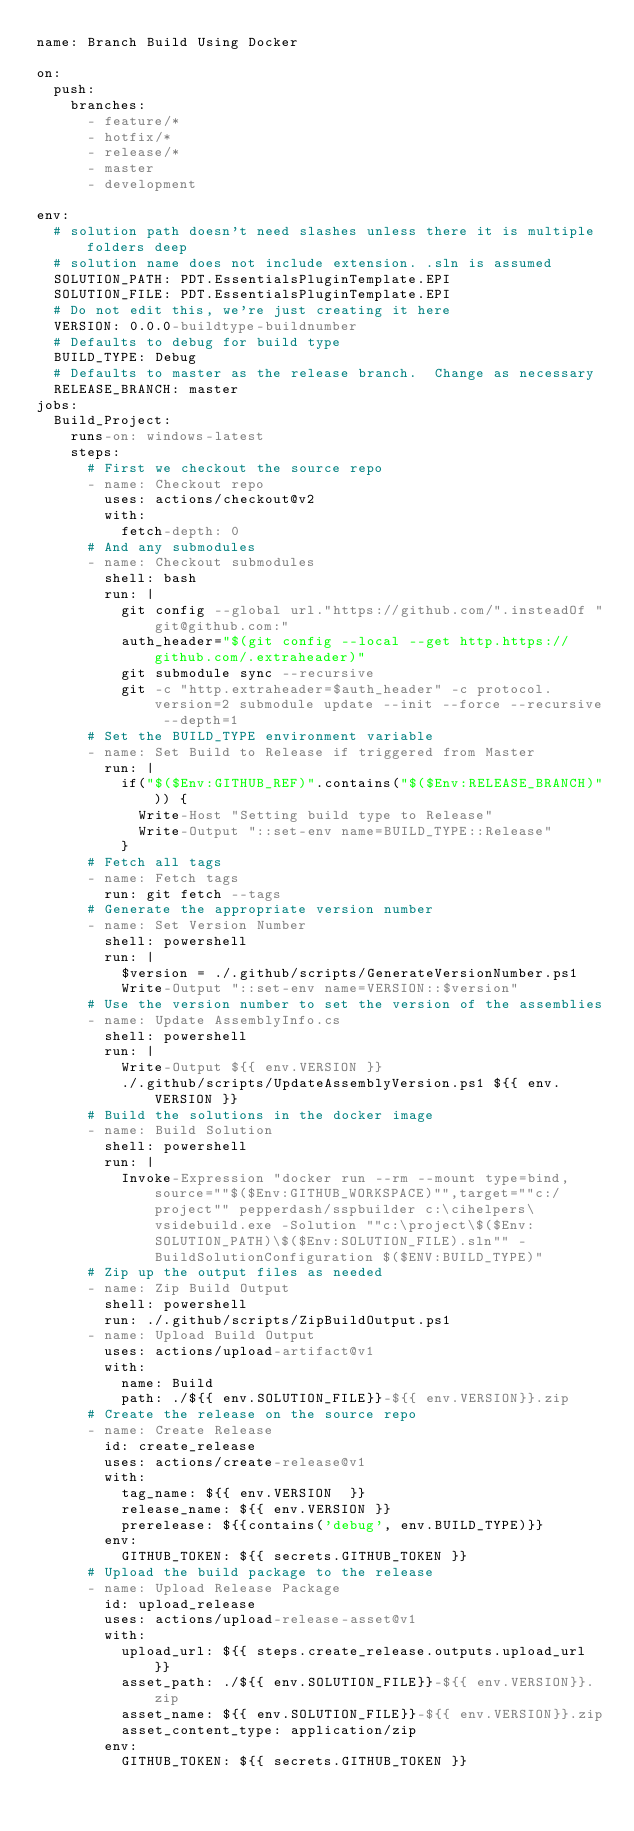Convert code to text. <code><loc_0><loc_0><loc_500><loc_500><_YAML_>name: Branch Build Using Docker

on:
  push:
    branches:
      - feature/*
      - hotfix/*
      - release/*
      - master
      - development

env:
  # solution path doesn't need slashes unless there it is multiple folders deep
  # solution name does not include extension. .sln is assumed
  SOLUTION_PATH: PDT.EssentialsPluginTemplate.EPI
  SOLUTION_FILE: PDT.EssentialsPluginTemplate.EPI
  # Do not edit this, we're just creating it here
  VERSION: 0.0.0-buildtype-buildnumber
  # Defaults to debug for build type
  BUILD_TYPE: Debug
  # Defaults to master as the release branch.  Change as necessary
  RELEASE_BRANCH: master
jobs:
  Build_Project:
    runs-on: windows-latest
    steps:
      # First we checkout the source repo
      - name: Checkout repo
        uses: actions/checkout@v2
        with:
          fetch-depth: 0
      # And any submodules
      - name: Checkout submodules
        shell: bash
        run: |
          git config --global url."https://github.com/".insteadOf "git@github.com:"
          auth_header="$(git config --local --get http.https://github.com/.extraheader)"
          git submodule sync --recursive
          git -c "http.extraheader=$auth_header" -c protocol.version=2 submodule update --init --force --recursive --depth=1
      # Set the BUILD_TYPE environment variable
      - name: Set Build to Release if triggered from Master
        run: |
          if("$($Env:GITHUB_REF)".contains("$($Env:RELEASE_BRANCH)")) {
            Write-Host "Setting build type to Release"
            Write-Output "::set-env name=BUILD_TYPE::Release"
          }
      # Fetch all tags
      - name: Fetch tags
        run: git fetch --tags
      # Generate the appropriate version number
      - name: Set Version Number
        shell: powershell
        run: |
          $version = ./.github/scripts/GenerateVersionNumber.ps1
          Write-Output "::set-env name=VERSION::$version"
      # Use the version number to set the version of the assemblies
      - name: Update AssemblyInfo.cs
        shell: powershell
        run: |
          Write-Output ${{ env.VERSION }}
          ./.github/scripts/UpdateAssemblyVersion.ps1 ${{ env.VERSION }}
      # Build the solutions in the docker image
      - name: Build Solution
        shell: powershell
        run: |
          Invoke-Expression "docker run --rm --mount type=bind,source=""$($Env:GITHUB_WORKSPACE)"",target=""c:/project"" pepperdash/sspbuilder c:\cihelpers\vsidebuild.exe -Solution ""c:\project\$($Env:SOLUTION_PATH)\$($Env:SOLUTION_FILE).sln"" -BuildSolutionConfiguration $($ENV:BUILD_TYPE)"
      # Zip up the output files as needed
      - name: Zip Build Output
        shell: powershell
        run: ./.github/scripts/ZipBuildOutput.ps1
      - name: Upload Build Output
        uses: actions/upload-artifact@v1
        with:
          name: Build
          path: ./${{ env.SOLUTION_FILE}}-${{ env.VERSION}}.zip
      # Create the release on the source repo
      - name: Create Release
        id: create_release
        uses: actions/create-release@v1
        with:
          tag_name: ${{ env.VERSION  }}
          release_name: ${{ env.VERSION }}
          prerelease: ${{contains('debug', env.BUILD_TYPE)}}
        env:
          GITHUB_TOKEN: ${{ secrets.GITHUB_TOKEN }}
      # Upload the build package to the release
      - name: Upload Release Package
        id: upload_release
        uses: actions/upload-release-asset@v1
        with:
          upload_url: ${{ steps.create_release.outputs.upload_url }}
          asset_path: ./${{ env.SOLUTION_FILE}}-${{ env.VERSION}}.zip
          asset_name: ${{ env.SOLUTION_FILE}}-${{ env.VERSION}}.zip
          asset_content_type: application/zip
        env:
          GITHUB_TOKEN: ${{ secrets.GITHUB_TOKEN }}
</code> 